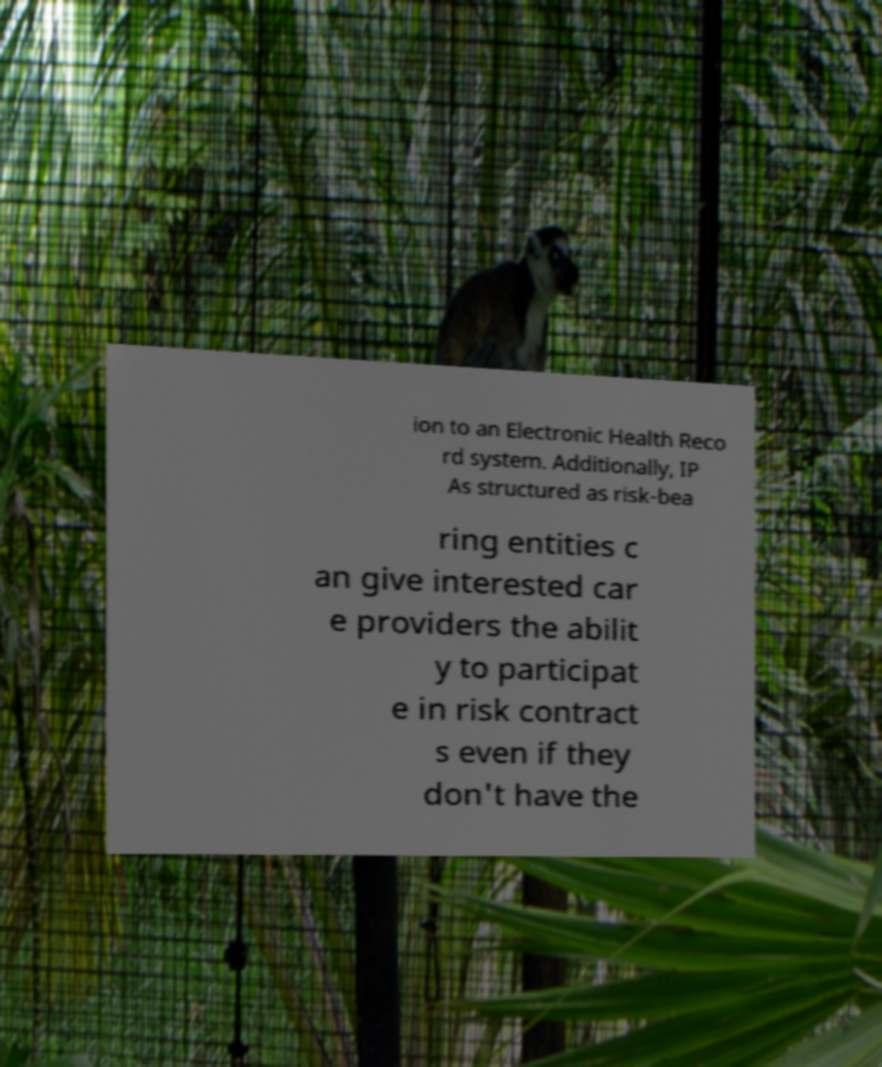There's text embedded in this image that I need extracted. Can you transcribe it verbatim? ion to an Electronic Health Reco rd system. Additionally, IP As structured as risk-bea ring entities c an give interested car e providers the abilit y to participat e in risk contract s even if they don't have the 